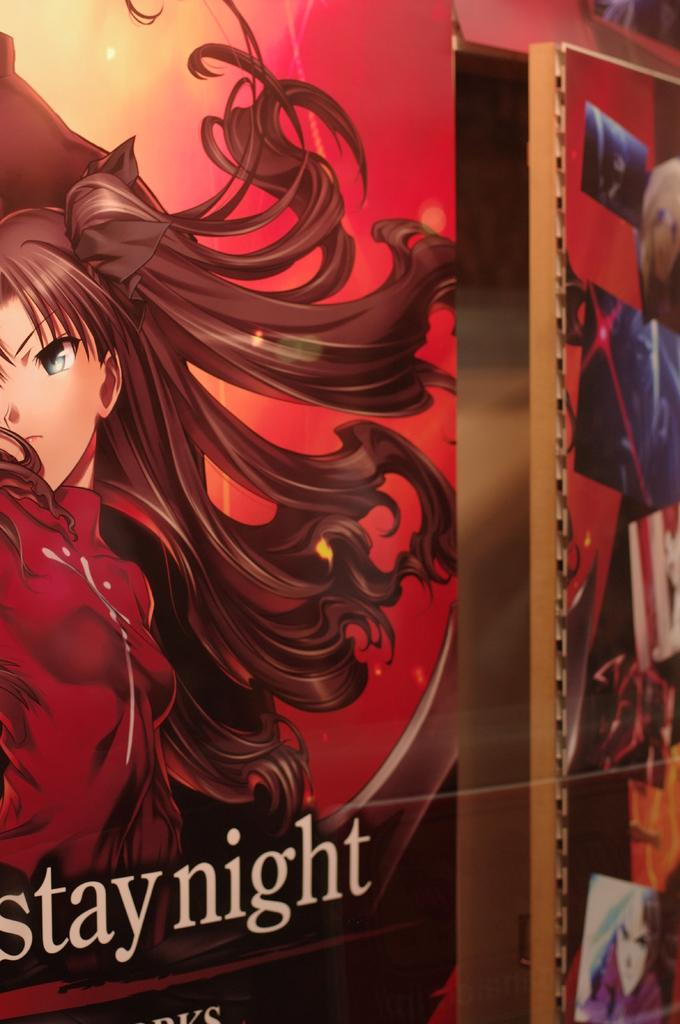What objects are present in the image that are used for displaying photos? There are photo frames in the image. Is there any text visible in the image? Yes, there is text visible at the bottom of the image. What type of berry is being used as a pest control method in the image? There is no berry or pest control method present in the image. 